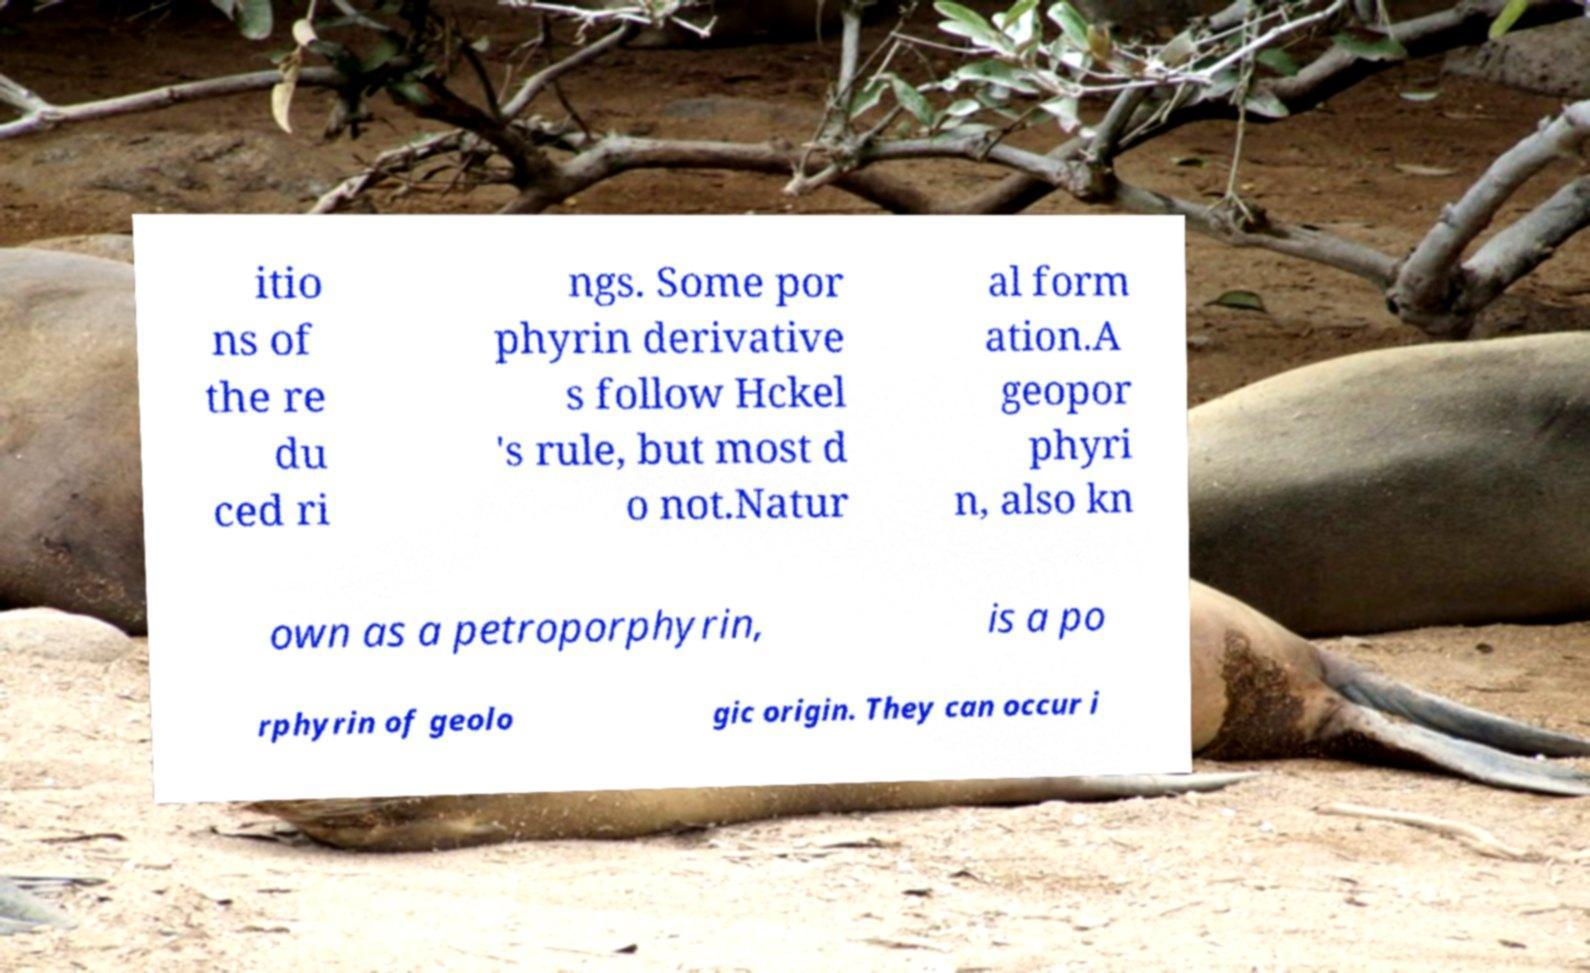Please read and relay the text visible in this image. What does it say? itio ns of the re du ced ri ngs. Some por phyrin derivative s follow Hckel 's rule, but most d o not.Natur al form ation.A geopor phyri n, also kn own as a petroporphyrin, is a po rphyrin of geolo gic origin. They can occur i 